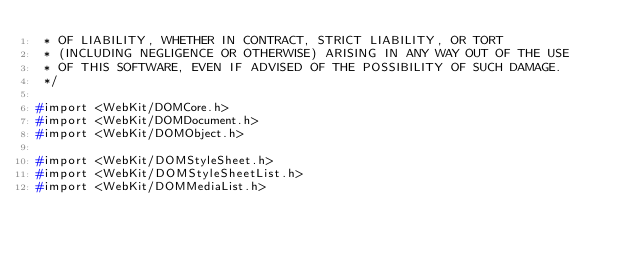Convert code to text. <code><loc_0><loc_0><loc_500><loc_500><_C_> * OF LIABILITY, WHETHER IN CONTRACT, STRICT LIABILITY, OR TORT
 * (INCLUDING NEGLIGENCE OR OTHERWISE) ARISING IN ANY WAY OUT OF THE USE
 * OF THIS SOFTWARE, EVEN IF ADVISED OF THE POSSIBILITY OF SUCH DAMAGE. 
 */

#import <WebKit/DOMCore.h>
#import <WebKit/DOMDocument.h>
#import <WebKit/DOMObject.h>

#import <WebKit/DOMStyleSheet.h>
#import <WebKit/DOMStyleSheetList.h>
#import <WebKit/DOMMediaList.h>
</code> 